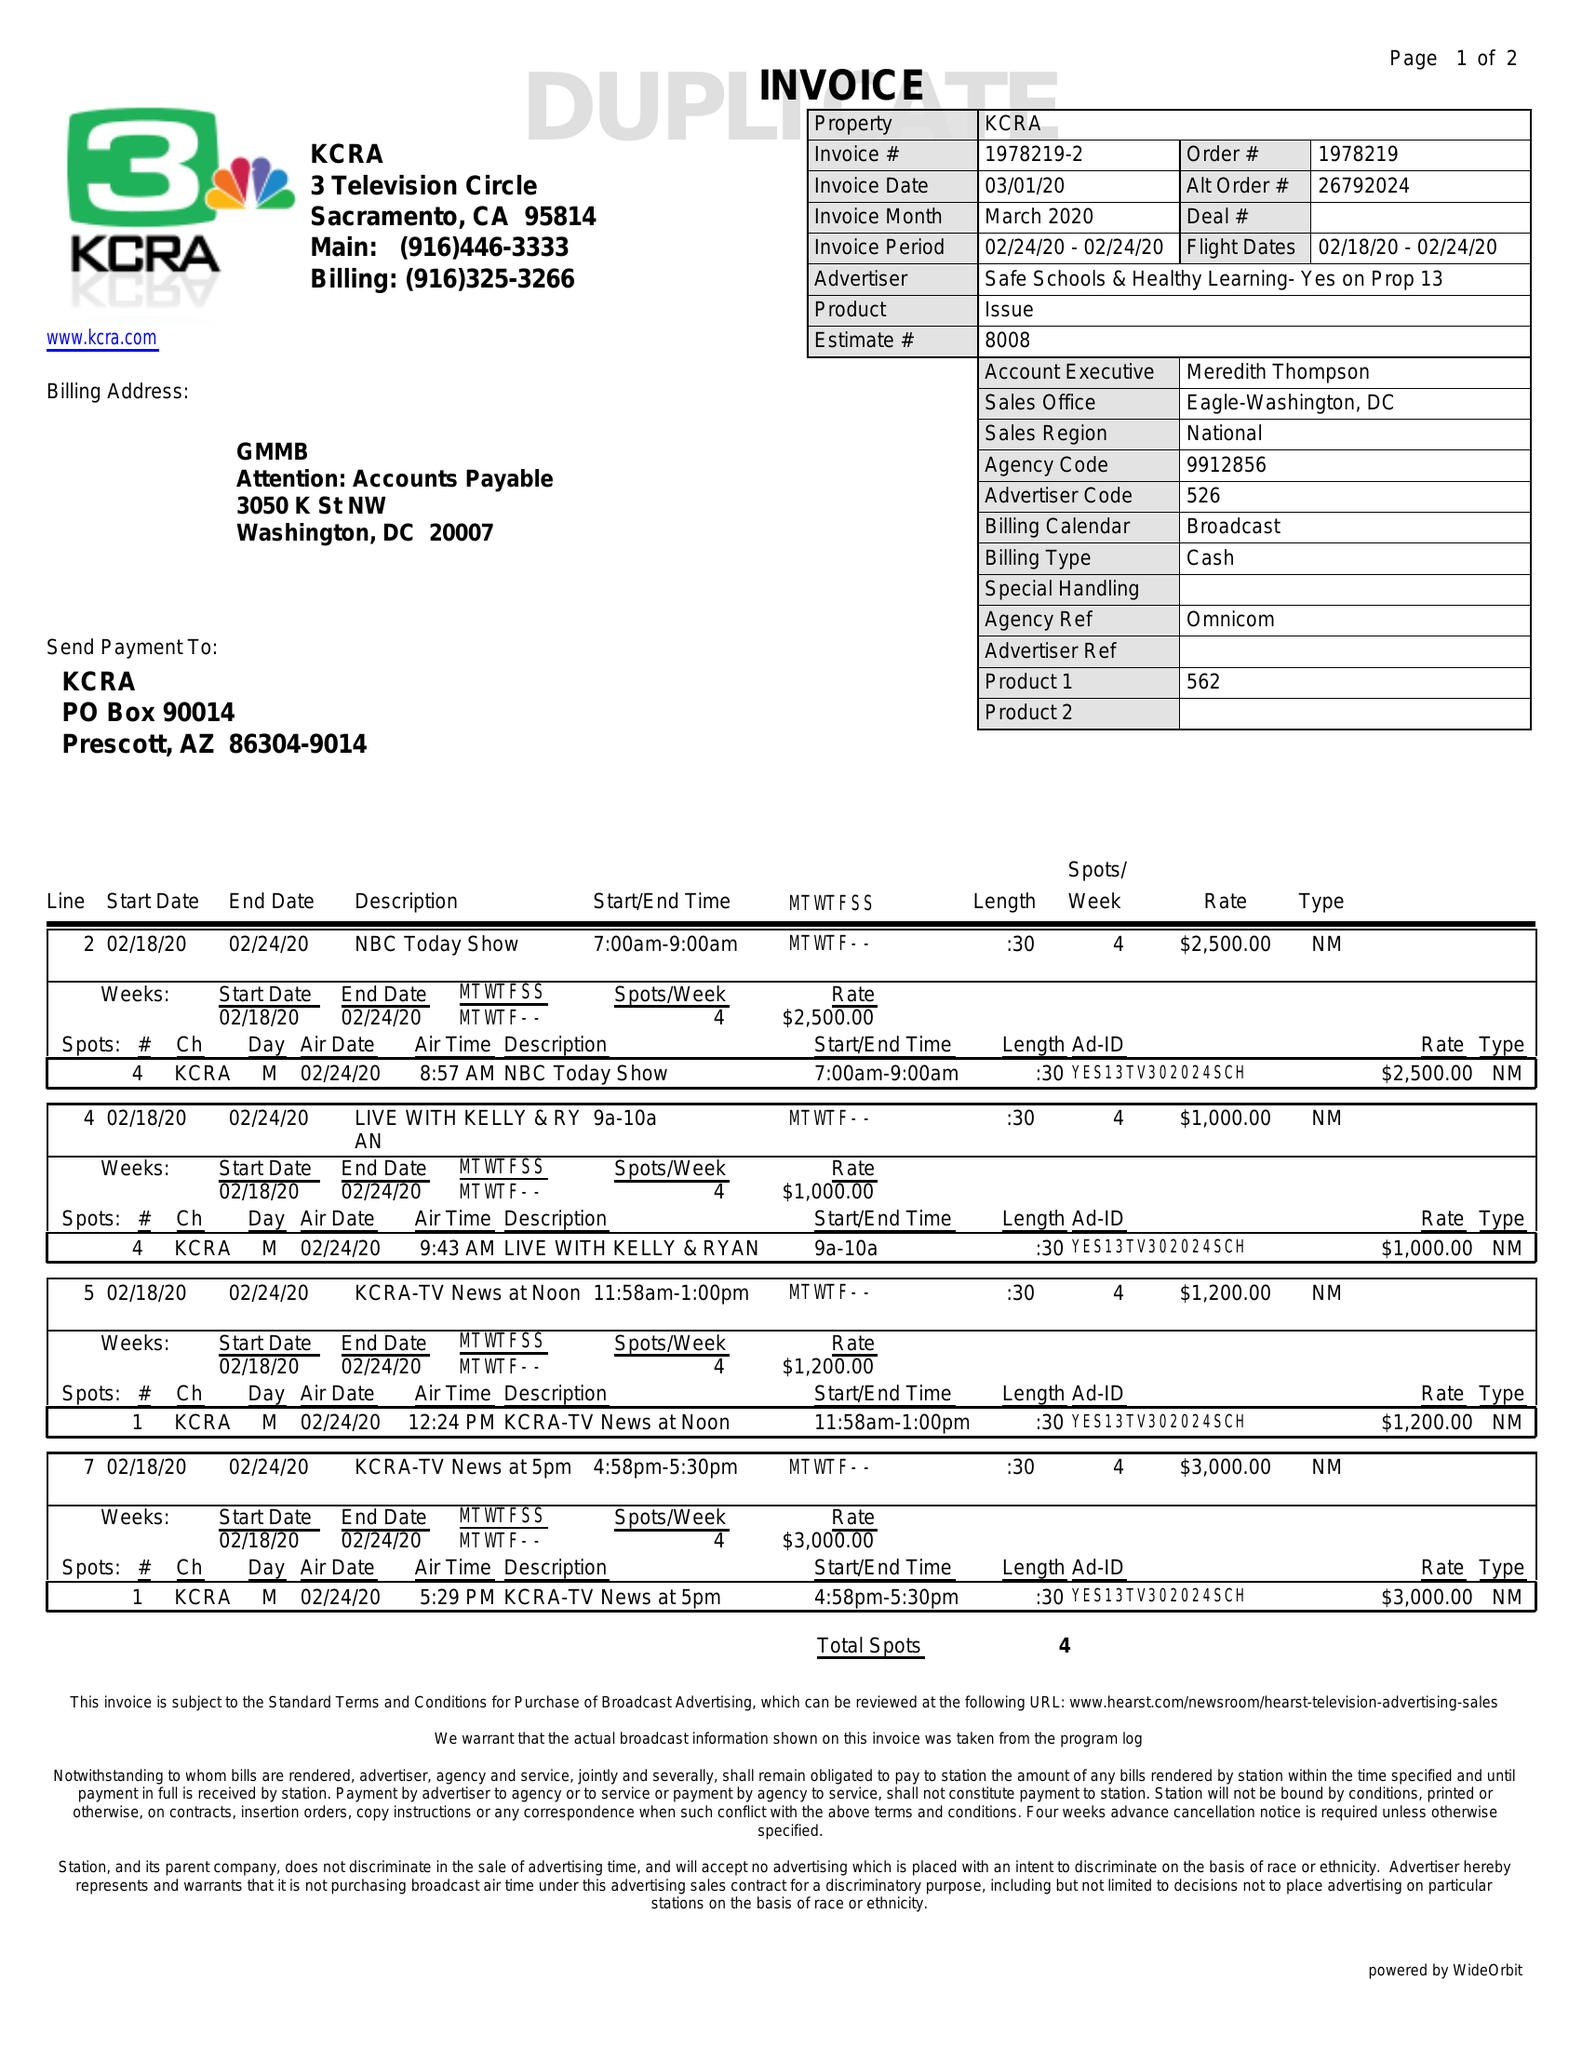What is the value for the contract_num?
Answer the question using a single word or phrase. 1978219 